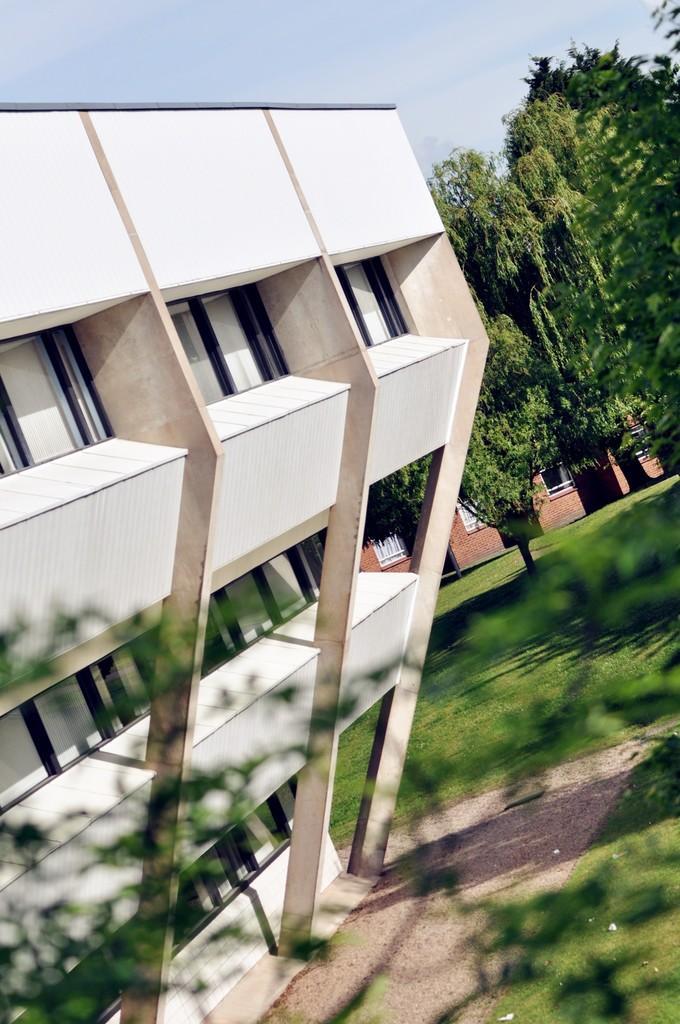How would you summarize this image in a sentence or two? In this picture we can see yard with trees and buildings and behind the buildings there is a sky. 